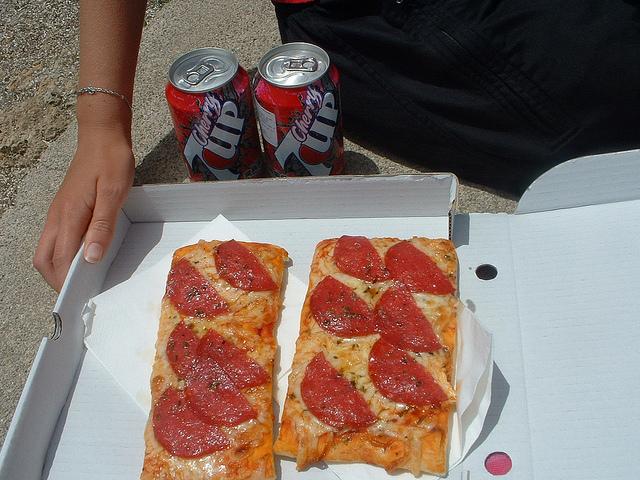How many little pizzas are there?
Concise answer only. 2. Does the pizza have vegetables or meat?
Be succinct. Meat. What color are the cans?
Write a very short answer. Red. Which plate has more slices?
Short answer required. Right. Are there pepperoni slices on the square piece of pizza in this image?
Short answer required. Yes. Is this a vegetable pizza?
Answer briefly. No. What are the people drinking?
Quick response, please. Cherry 7 up. What kind of cups are they going to use?
Concise answer only. 0. How many slices of pizza are shown?
Be succinct. 2. How many snacks are there?
Keep it brief. 1. 